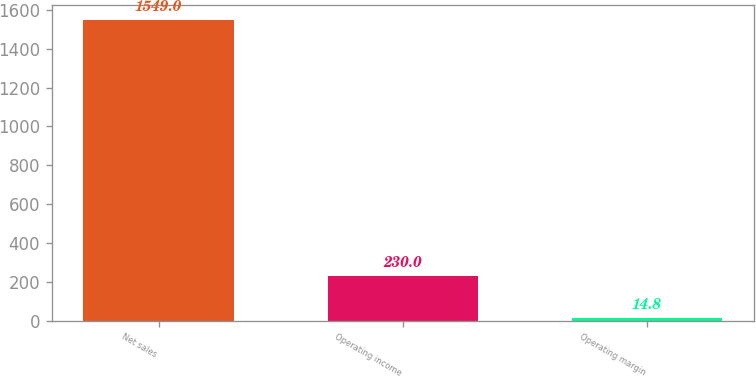<chart> <loc_0><loc_0><loc_500><loc_500><bar_chart><fcel>Net sales<fcel>Operating income<fcel>Operating margin<nl><fcel>1549<fcel>230<fcel>14.8<nl></chart> 